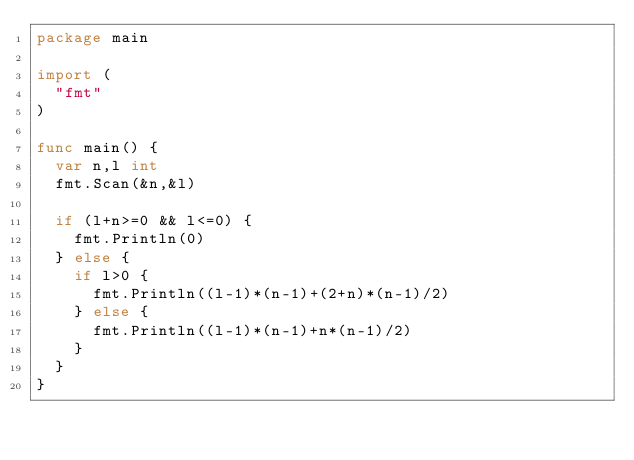Convert code to text. <code><loc_0><loc_0><loc_500><loc_500><_Go_>package main

import (
	"fmt"
)

func main() {
	var n,l int
	fmt.Scan(&n,&l)

	if (l+n>=0 && l<=0) {
		fmt.Println(0)
	} else {
		if l>0 {
			fmt.Println((l-1)*(n-1)+(2+n)*(n-1)/2)
		} else {
			fmt.Println((l-1)*(n-1)+n*(n-1)/2)
		}
	}
}
</code> 